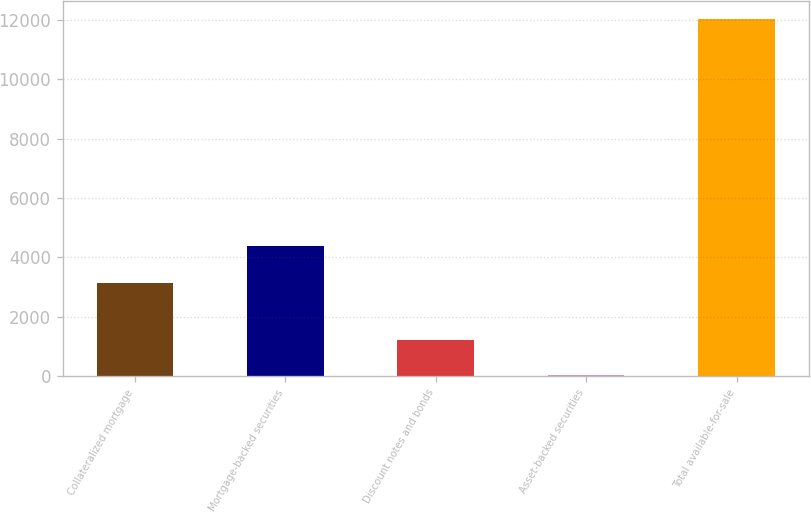<chart> <loc_0><loc_0><loc_500><loc_500><bar_chart><fcel>Collateralized mortgage<fcel>Mortgage-backed securities<fcel>Discount notes and bonds<fcel>Asset-backed securities<fcel>Total available-for-sale<nl><fcel>3133<fcel>4372<fcel>1232.8<fcel>32<fcel>12040<nl></chart> 